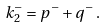<formula> <loc_0><loc_0><loc_500><loc_500>k _ { 2 } ^ { - } = p ^ { - } + q ^ { - } \, .</formula> 